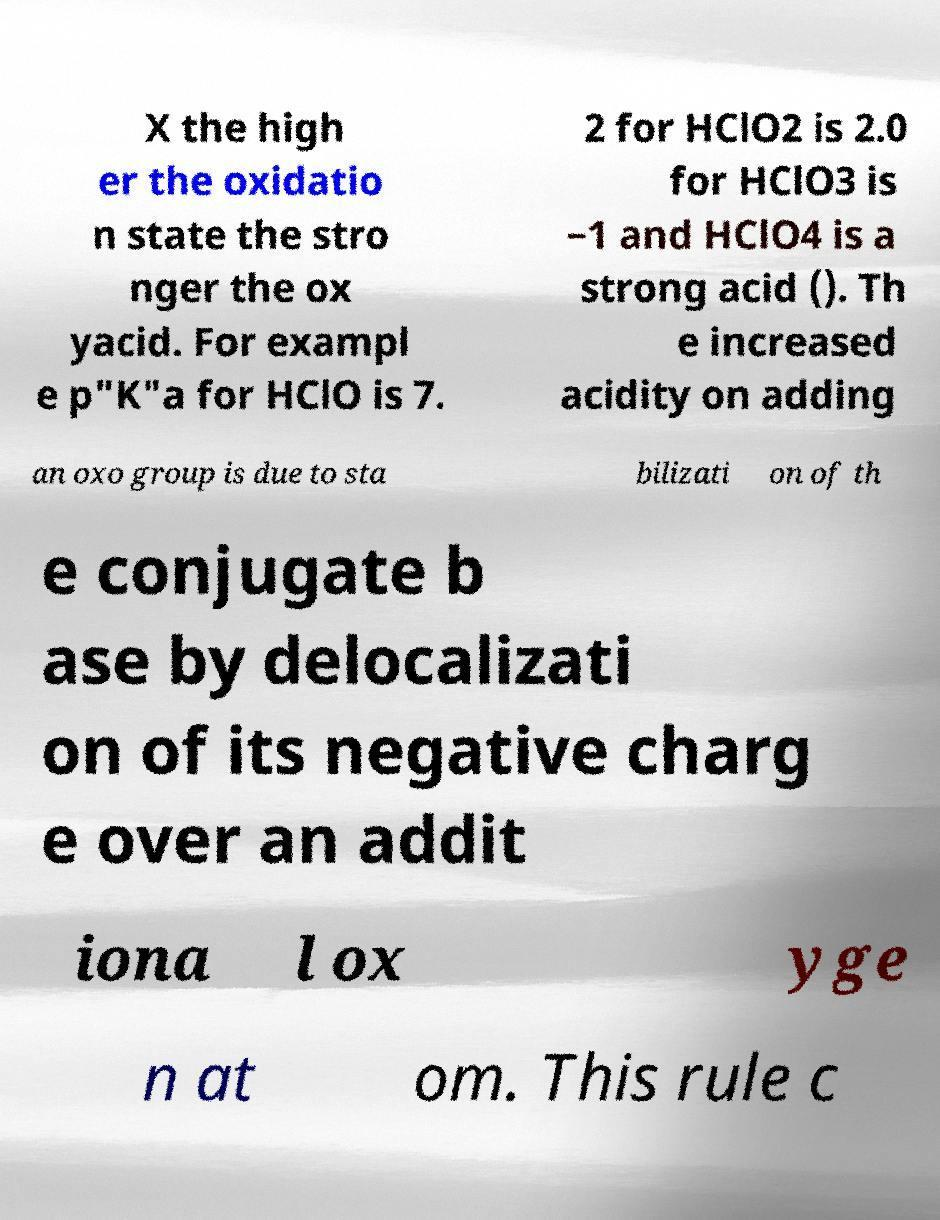Could you extract and type out the text from this image? X the high er the oxidatio n state the stro nger the ox yacid. For exampl e p"K"a for HClO is 7. 2 for HClO2 is 2.0 for HClO3 is −1 and HClO4 is a strong acid (). Th e increased acidity on adding an oxo group is due to sta bilizati on of th e conjugate b ase by delocalizati on of its negative charg e over an addit iona l ox yge n at om. This rule c 